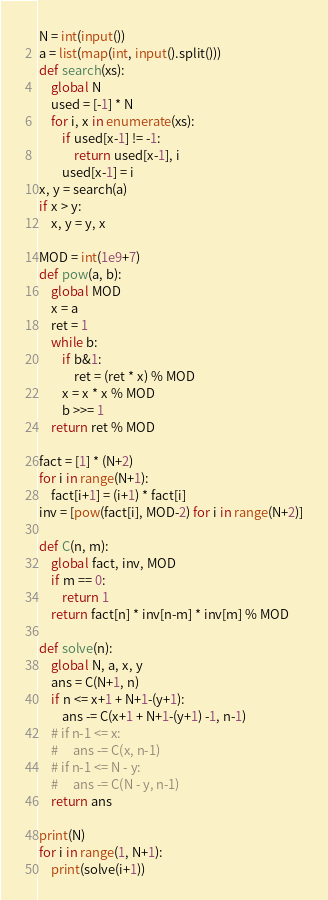<code> <loc_0><loc_0><loc_500><loc_500><_Python_>N = int(input())
a = list(map(int, input().split()))
def search(xs):
    global N
    used = [-1] * N
    for i, x in enumerate(xs):
        if used[x-1] != -1:
            return used[x-1], i
        used[x-1] = i
x, y = search(a)
if x > y:
    x, y = y, x

MOD = int(1e9+7)
def pow(a, b):
    global MOD
    x = a
    ret = 1
    while b:
        if b&1:
            ret = (ret * x) % MOD
        x = x * x % MOD
        b >>= 1
    return ret % MOD

fact = [1] * (N+2)
for i in range(N+1):
    fact[i+1] = (i+1) * fact[i]
inv = [pow(fact[i], MOD-2) for i in range(N+2)]

def C(n, m):
    global fact, inv, MOD
    if m == 0:
        return 1
    return fact[n] * inv[n-m] * inv[m] % MOD

def solve(n):
    global N, a, x, y
    ans = C(N+1, n)
    if n <= x+1 + N+1-(y+1):
        ans -= C(x+1 + N+1-(y+1) -1, n-1)
    # if n-1 <= x:
    #     ans -= C(x, n-1)
    # if n-1 <= N - y:
    #     ans -= C(N - y, n-1)
    return ans

print(N)
for i in range(1, N+1):
    print(solve(i+1))
</code> 